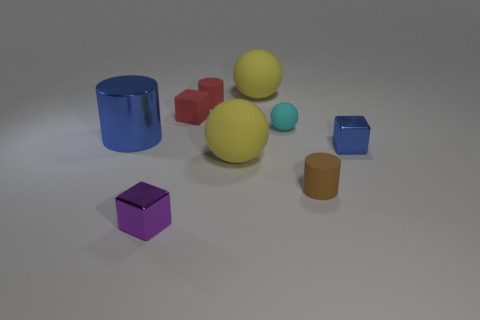What materials do these objects appear to be made from? These objects appear to be 3D renderings and simulate materials like rubber and glass, indicated by their various levels of shine and transparency. Can you tell which objects are translucent? Certainly, the blue cylindrical object on the left displays translucency, suggesting it might represent a glass-like material. 